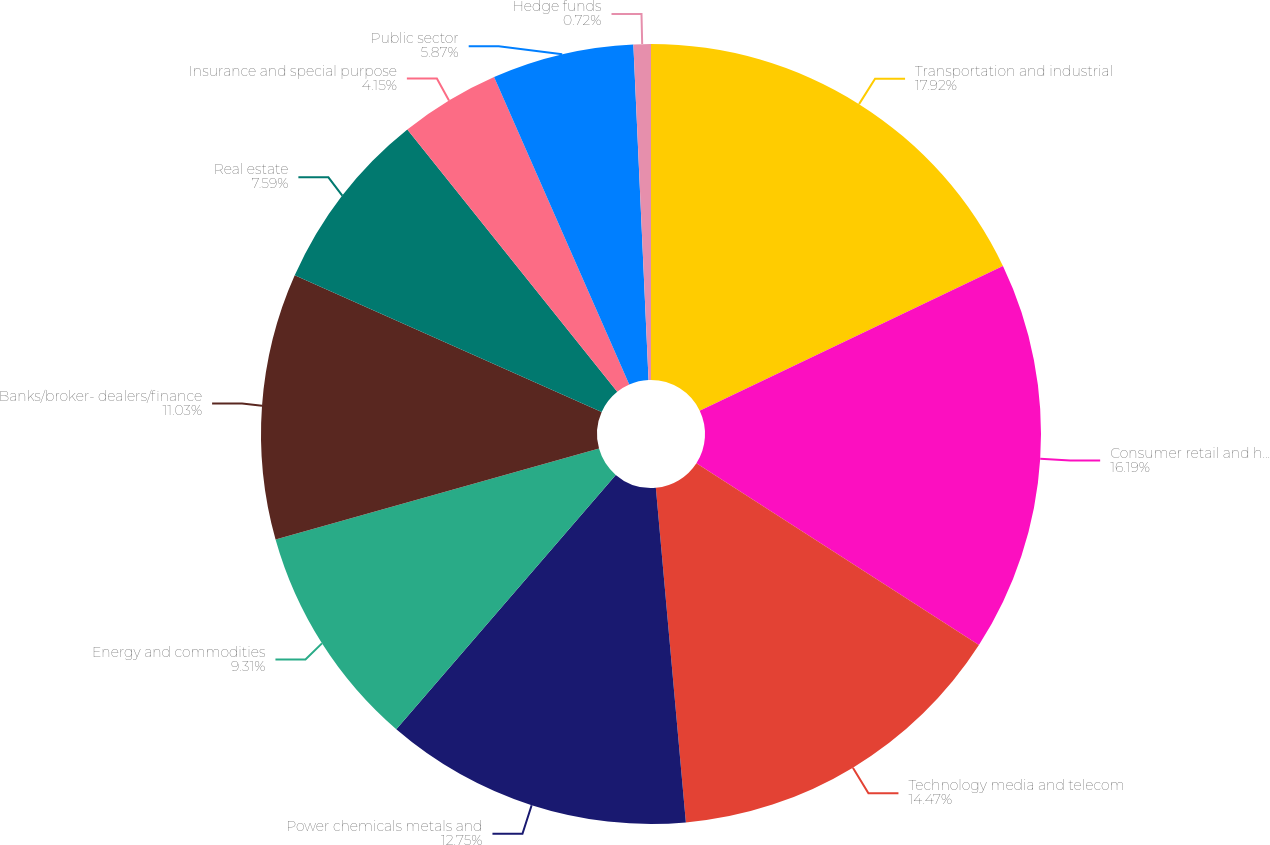<chart> <loc_0><loc_0><loc_500><loc_500><pie_chart><fcel>Transportation and industrial<fcel>Consumer retail and health<fcel>Technology media and telecom<fcel>Power chemicals metals and<fcel>Energy and commodities<fcel>Banks/broker- dealers/finance<fcel>Real estate<fcel>Insurance and special purpose<fcel>Public sector<fcel>Hedge funds<nl><fcel>17.91%<fcel>16.19%<fcel>14.47%<fcel>12.75%<fcel>9.31%<fcel>11.03%<fcel>7.59%<fcel>4.15%<fcel>5.87%<fcel>0.72%<nl></chart> 